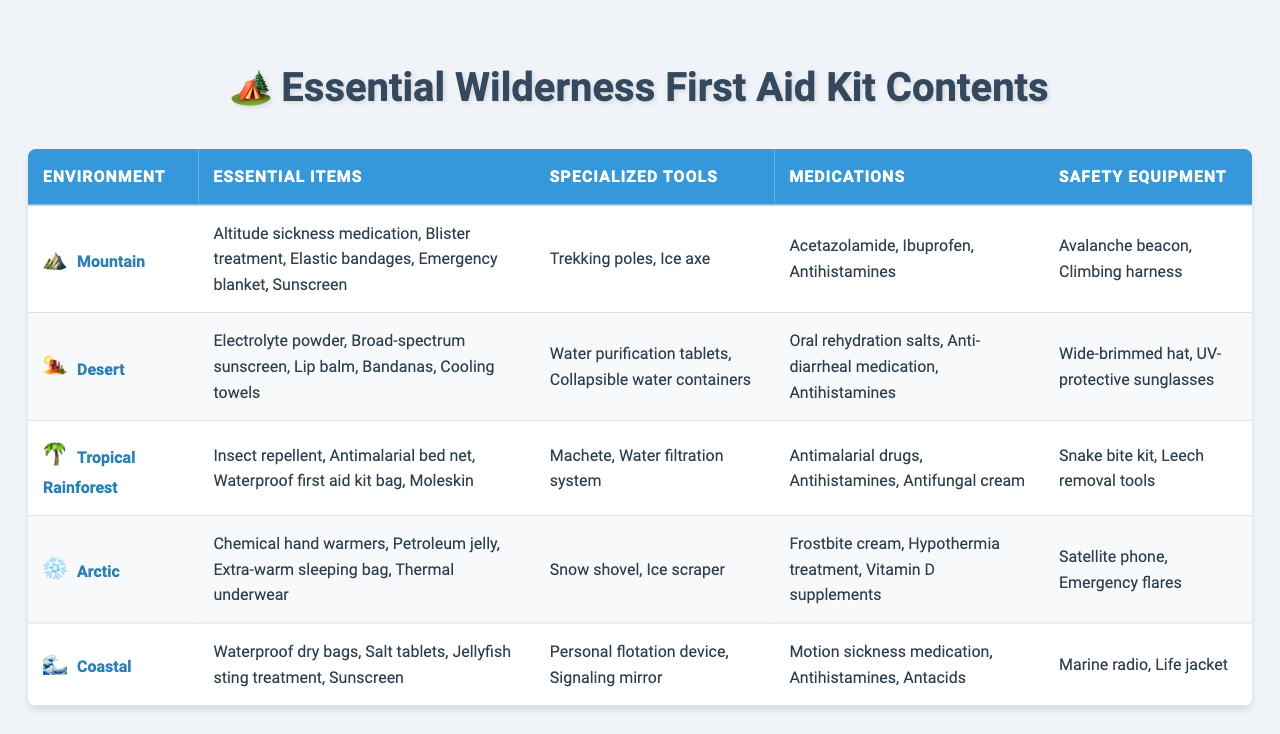What are the essential items for a mountain environment? According to the table, the essential items for a mountain environment include altitude sickness medication, blister treatment, elastic bandages, emergency blanket, and sunscreen.
Answer: Altitude sickness medication, blister treatment, elastic bandages, emergency blanket, sunscreen Which environment requires a waterproof first aid kit bag? The table indicates that a waterproof first aid kit bag is essential in a tropical rainforest environment.
Answer: Tropical Rainforest Are trekking poles considered specialized tools for coastal environments? The table shows that trekking poles are listed as specialized tools for mountain environments, not coastal environments, so this statement is false.
Answer: False What medications are common in both desert and coastal environments? Reviewing the table shows that antihistamines are the only common medication listed for both desert and coastal environments.
Answer: Antihistamines Which environment has the most specialized tools listed? By examining the table, the mountain environment and tropical rainforest environment both have two specialized tools listed, which is the highest count among the environments.
Answer: Mountain and Tropical Rainforest Do all environments require sunscreen as part of their essential items? The table indicates that sunscreen is listed as an essential item for mountain, desert, and coastal environments, but not for tropical rainforest and arctic environments. Therefore, not all require it.
Answer: No How many environments include insect repellent in their essential items? The table shows that only the tropical rainforest environment includes insect repellent in its essential items. Thus, the count is one.
Answer: One Which environment combines chemical hand warmers with extra-warm sleeping bags as essential items? Looking at the table, these items are specifically essential for the arctic environment.
Answer: Arctic List all the medications needed for the desert environment. The table states that the medications needed for the desert environment are oral rehydration salts, anti-diarrheal medication, and antihistamines.
Answer: Oral rehydration salts, anti-diarrheal medication, antihistamines Is a satellite phone essential for environments other than arctic? Based on the table, the satellite phone is listed as safety equipment only for the arctic environment, meaning it's not essential for other environments.
Answer: No 